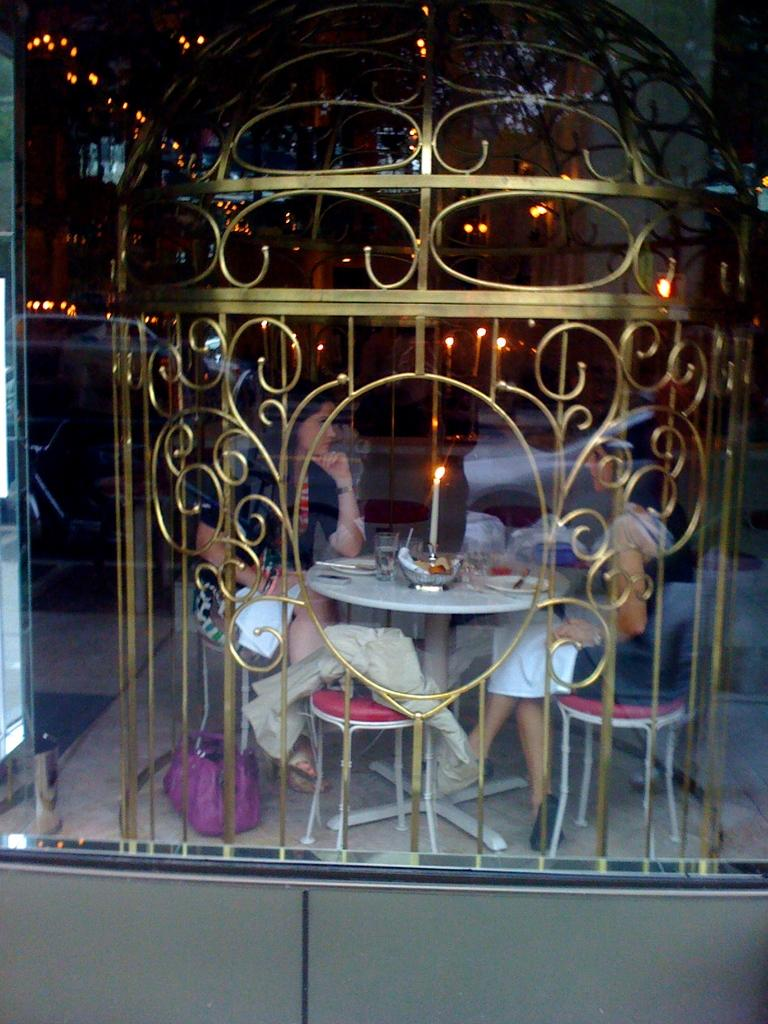What object can be seen in the image that is typically used for drinking? There is a glass in the image that is typically used for drinking. How many persons are sitting in the image? Two persons are sitting on chairs in the image. What is the purpose of the candle in the image? The purpose of the candle in the image is not specified, but it could be for lighting or decoration. What objects are on the table in the image? There is a glass, a bowl, and a plate on the table in the image. What is present on the table that indicates a meal is being served? There is food on the table in the image, which indicates a meal is being served. What part of the room can be seen in the image? The floor is visible in the image. What is the title of the book that the persons are reading in the image? There is no book present in the image, so there is no title to mention. 